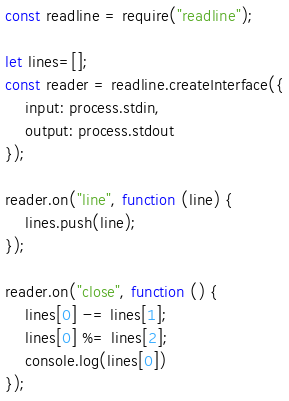<code> <loc_0><loc_0><loc_500><loc_500><_JavaScript_>const readline = require("readline");

let lines=[];
const reader = readline.createInterface({
	input: process.stdin,
	output: process.stdout
});

reader.on("line", function (line) {
    lines.push(line);
});

reader.on("close", function () {
    lines[0] -= lines[1];
    lines[0] %= lines[2];
    console.log(lines[0])
});</code> 